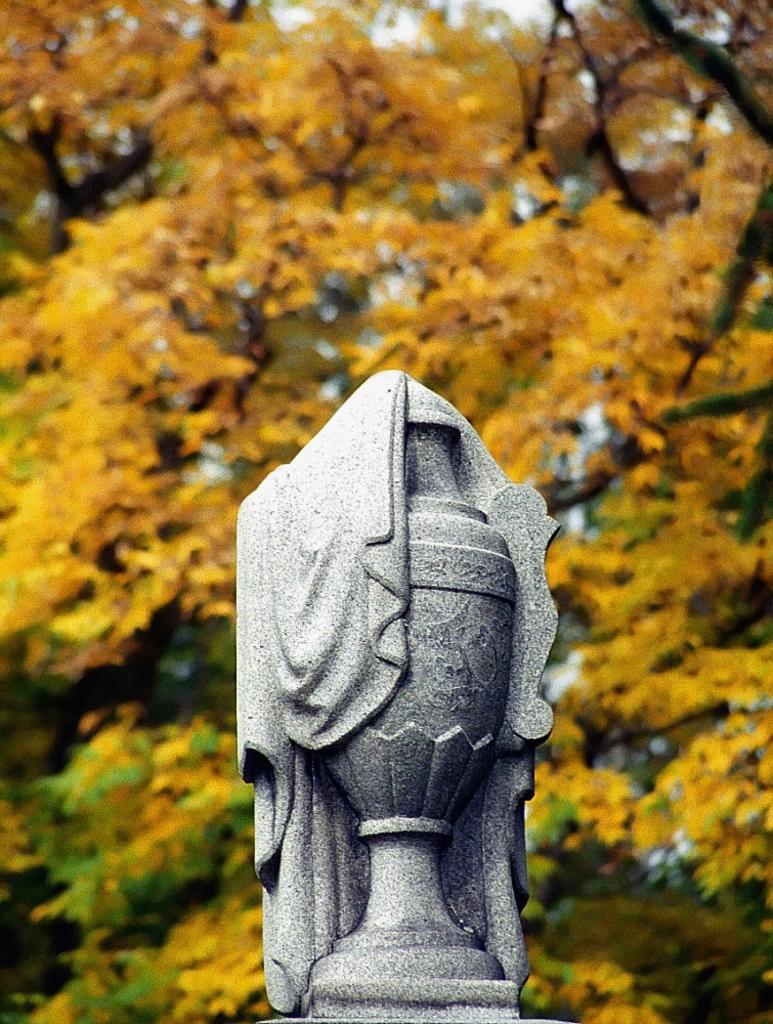Could you give a brief overview of what you see in this image? In this picture there is a statue in the foreground. At the back there are trees. At the top it looks like sky. 